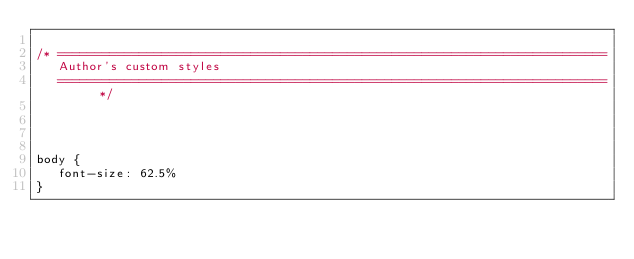Convert code to text. <code><loc_0><loc_0><loc_500><loc_500><_CSS_>
/* ==========================================================================
   Author's custom styles
   ========================================================================== */




body {
   font-size: 62.5%
}












</code> 